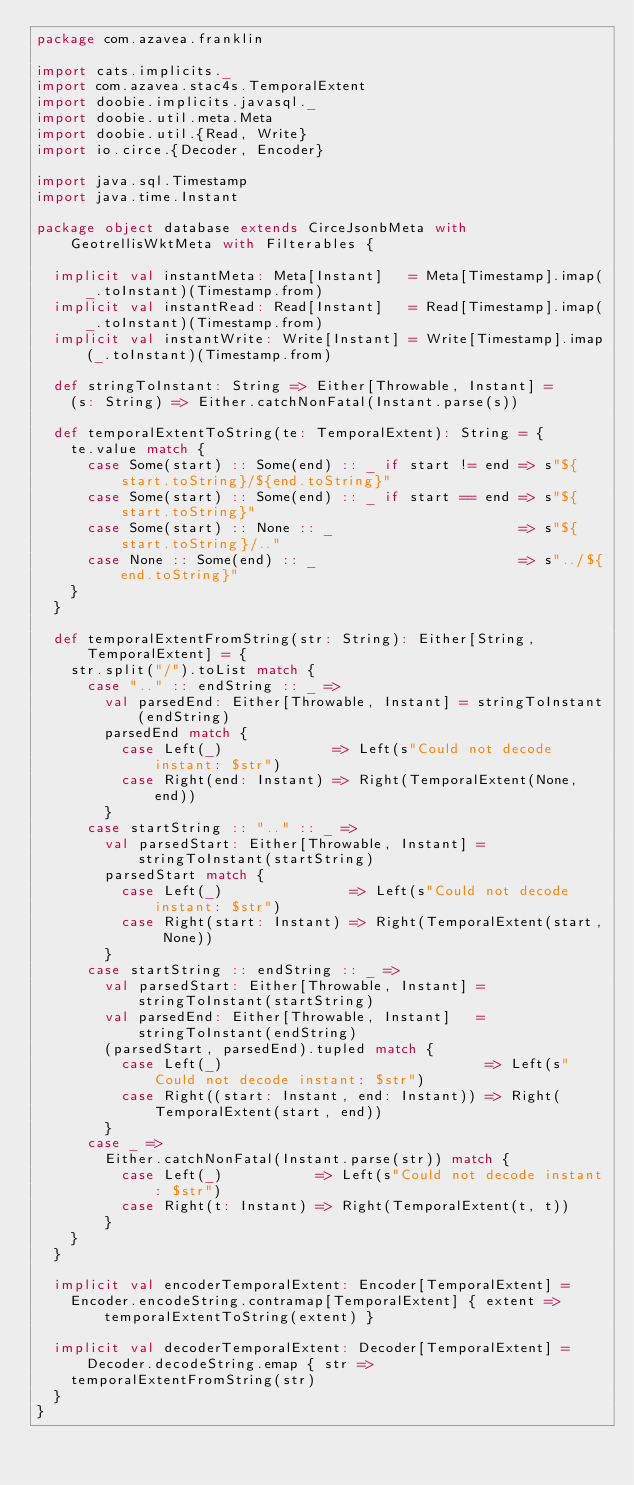<code> <loc_0><loc_0><loc_500><loc_500><_Scala_>package com.azavea.franklin

import cats.implicits._
import com.azavea.stac4s.TemporalExtent
import doobie.implicits.javasql._
import doobie.util.meta.Meta
import doobie.util.{Read, Write}
import io.circe.{Decoder, Encoder}

import java.sql.Timestamp
import java.time.Instant

package object database extends CirceJsonbMeta with GeotrellisWktMeta with Filterables {

  implicit val instantMeta: Meta[Instant]   = Meta[Timestamp].imap(_.toInstant)(Timestamp.from)
  implicit val instantRead: Read[Instant]   = Read[Timestamp].imap(_.toInstant)(Timestamp.from)
  implicit val instantWrite: Write[Instant] = Write[Timestamp].imap(_.toInstant)(Timestamp.from)

  def stringToInstant: String => Either[Throwable, Instant] =
    (s: String) => Either.catchNonFatal(Instant.parse(s))

  def temporalExtentToString(te: TemporalExtent): String = {
    te.value match {
      case Some(start) :: Some(end) :: _ if start != end => s"${start.toString}/${end.toString}"
      case Some(start) :: Some(end) :: _ if start == end => s"${start.toString}"
      case Some(start) :: None :: _                      => s"${start.toString}/.."
      case None :: Some(end) :: _                        => s"../${end.toString}"
    }
  }

  def temporalExtentFromString(str: String): Either[String, TemporalExtent] = {
    str.split("/").toList match {
      case ".." :: endString :: _ =>
        val parsedEnd: Either[Throwable, Instant] = stringToInstant(endString)
        parsedEnd match {
          case Left(_)             => Left(s"Could not decode instant: $str")
          case Right(end: Instant) => Right(TemporalExtent(None, end))
        }
      case startString :: ".." :: _ =>
        val parsedStart: Either[Throwable, Instant] = stringToInstant(startString)
        parsedStart match {
          case Left(_)               => Left(s"Could not decode instant: $str")
          case Right(start: Instant) => Right(TemporalExtent(start, None))
        }
      case startString :: endString :: _ =>
        val parsedStart: Either[Throwable, Instant] = stringToInstant(startString)
        val parsedEnd: Either[Throwable, Instant]   = stringToInstant(endString)
        (parsedStart, parsedEnd).tupled match {
          case Left(_)                               => Left(s"Could not decode instant: $str")
          case Right((start: Instant, end: Instant)) => Right(TemporalExtent(start, end))
        }
      case _ =>
        Either.catchNonFatal(Instant.parse(str)) match {
          case Left(_)           => Left(s"Could not decode instant: $str")
          case Right(t: Instant) => Right(TemporalExtent(t, t))
        }
    }
  }

  implicit val encoderTemporalExtent: Encoder[TemporalExtent] =
    Encoder.encodeString.contramap[TemporalExtent] { extent => temporalExtentToString(extent) }

  implicit val decoderTemporalExtent: Decoder[TemporalExtent] = Decoder.decodeString.emap { str =>
    temporalExtentFromString(str)
  }
}
</code> 